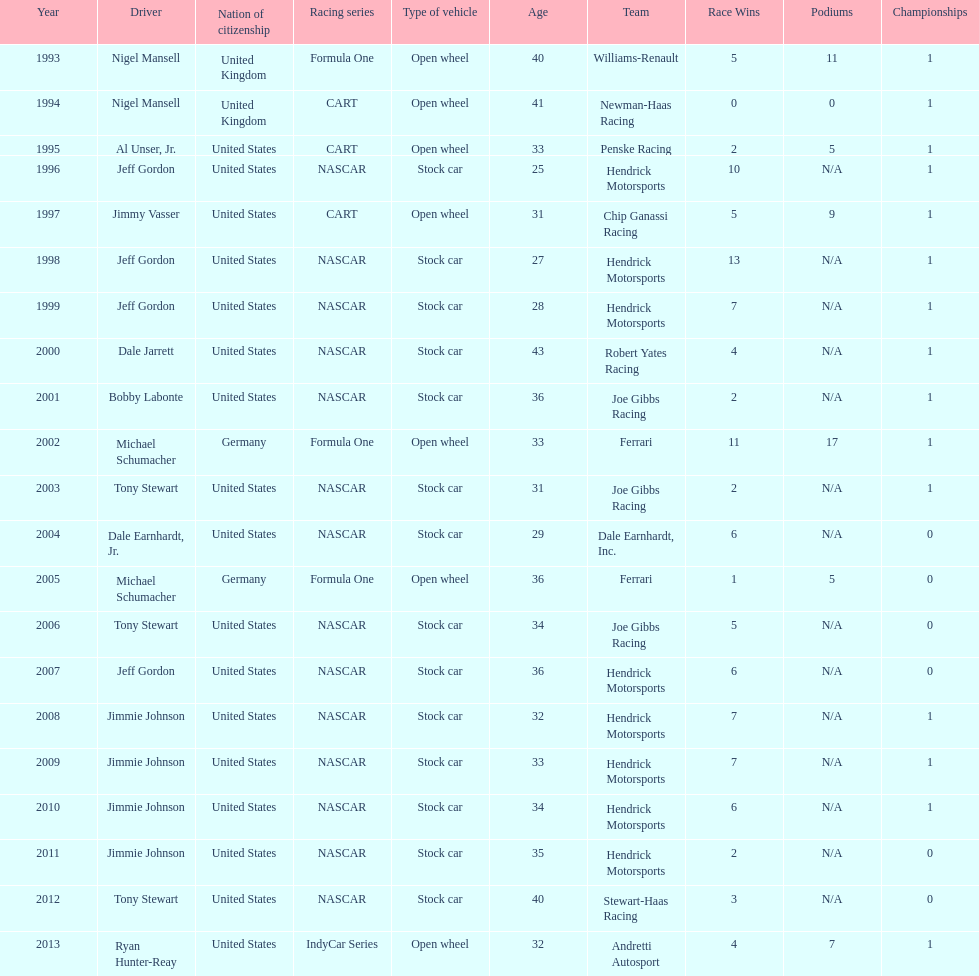Which racing series has the highest total of winners? NASCAR. 